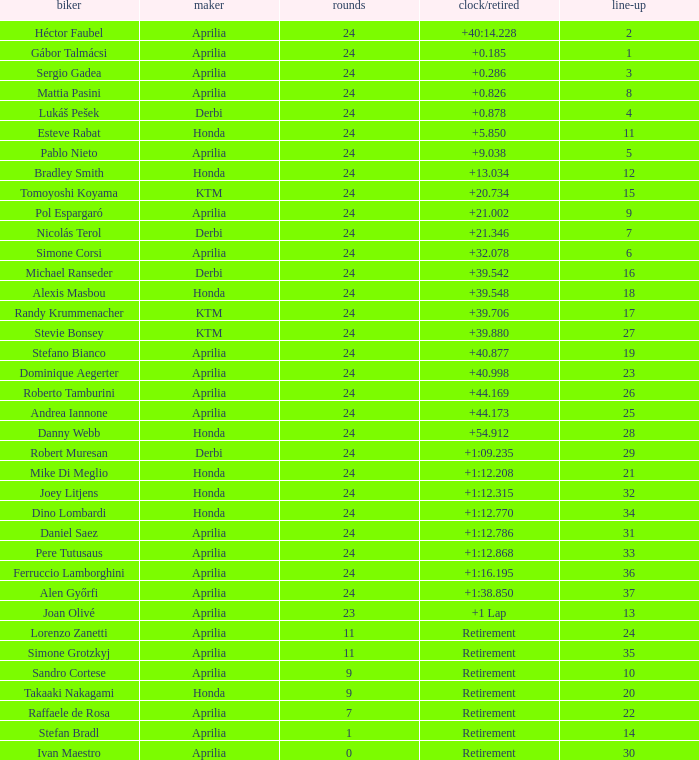How many grids have over 24 laps with a time/retired of +1:1 None. 